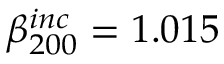Convert formula to latex. <formula><loc_0><loc_0><loc_500><loc_500>\beta _ { 2 0 0 } ^ { i n c } = 1 . 0 1 5</formula> 